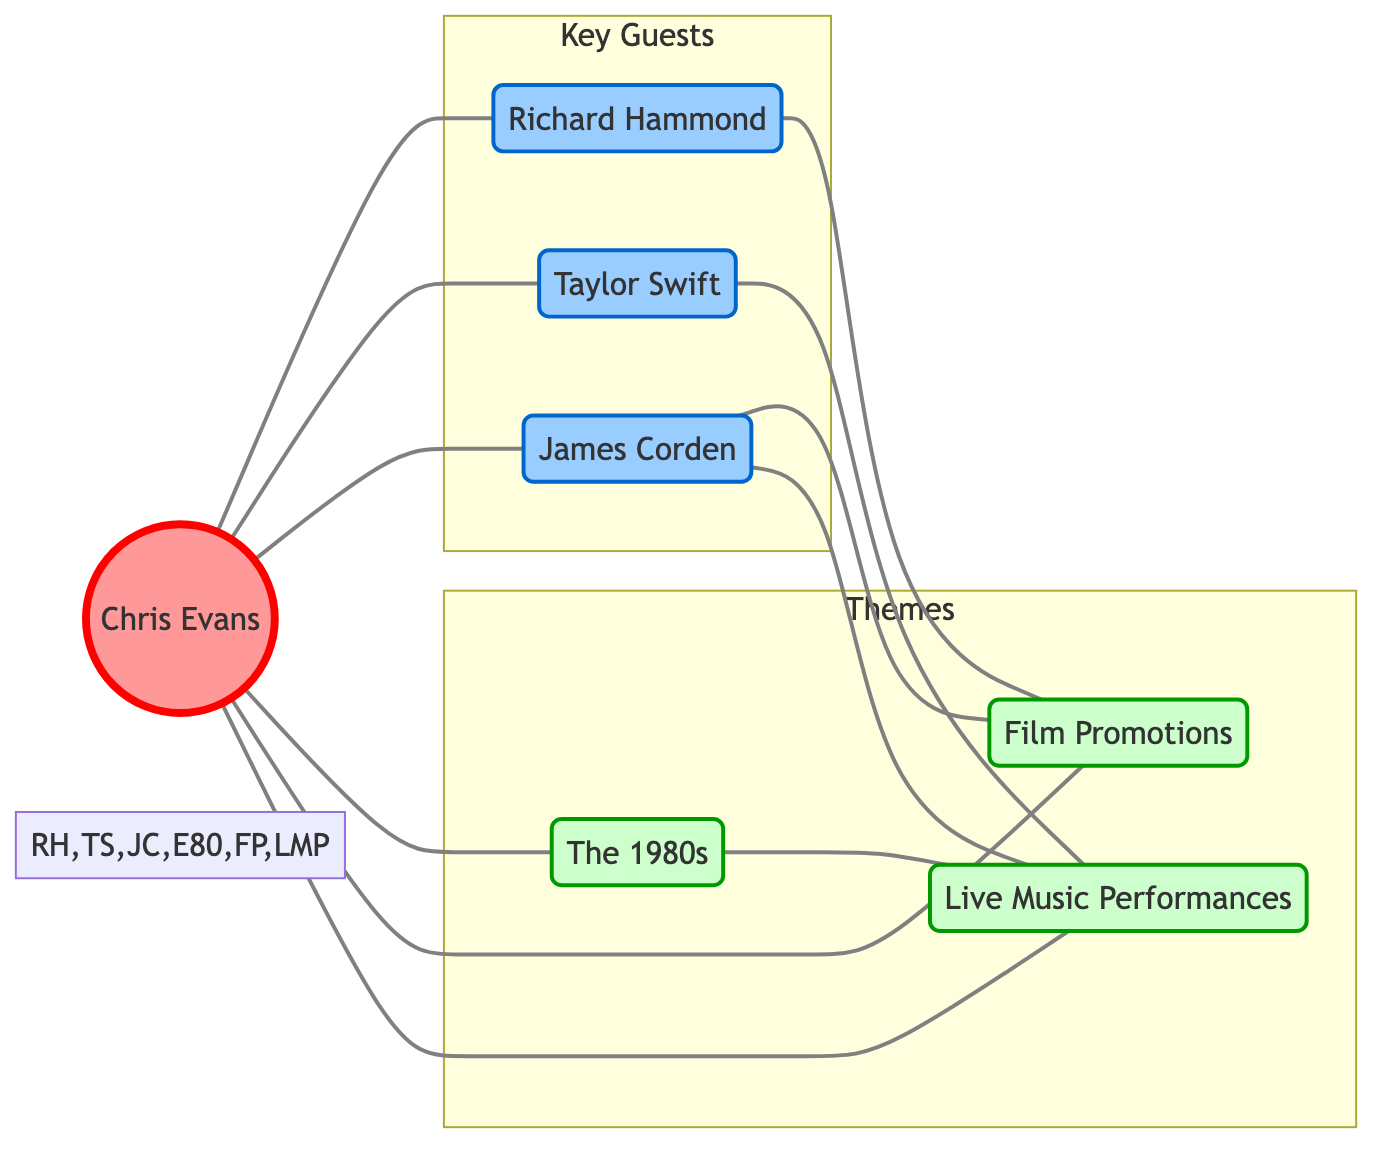What are the total number of nodes in the graph? The graph contains six nodes: Chris Evans, Richard Hammond, Taylor Swift, James Corden, The 1980s, and Film Promotions, and Live Music Performances. Counting them gives a total of 6 nodes.
Answer: 6 Which guest is connected to the most themes? James Corden has connections to both Film Promotions and Live Music Performances, which is two themes. Checking each guest, Richard Hammond is only connected to Film Promotions and Taylor Swift is only connected to Live Music Performances. Thus, James Corden is connected to the most themes.
Answer: James Corden How many themes are present in the graph? There are three themes in the graph: The 1980s, Film Promotions, and Live Music Performances. Counting them gives a total of 3 themes.
Answer: 3 Is Richard Hammond connected to Chris Evans? Richard Hammond is directly connected to Chris Evans as shown by a direct edge between them in the graph.
Answer: Yes Which theme does not connect to Richard Hammond? Richard Hammond is only connected to Film Promotions and not to The 1980s or Live Music Performances. Checking the edges reveals that he has no direct connection to these themes.
Answer: The 1980s, Live Music Performances How many total edges are in the graph? The graph has a total of 8 edges as seen in the connections listed between the nodes. Each relationship between the guests and themes are counted to arrive at this total.
Answer: 8 Which guest appears only once in the connections? Taylor Swift is connected to Chris Evans and Live Music Performances, which counts as only two connections when looking at all connections together. Other guests have more than one theme or additional connections.
Answer: Taylor Swift Which themes are connected to James Corden? James Corden is linked to Film Promotions and Live Music Performances in the graph. By checking the edges, we see both themes connected to him.
Answer: Film Promotions, Live Music Performances 